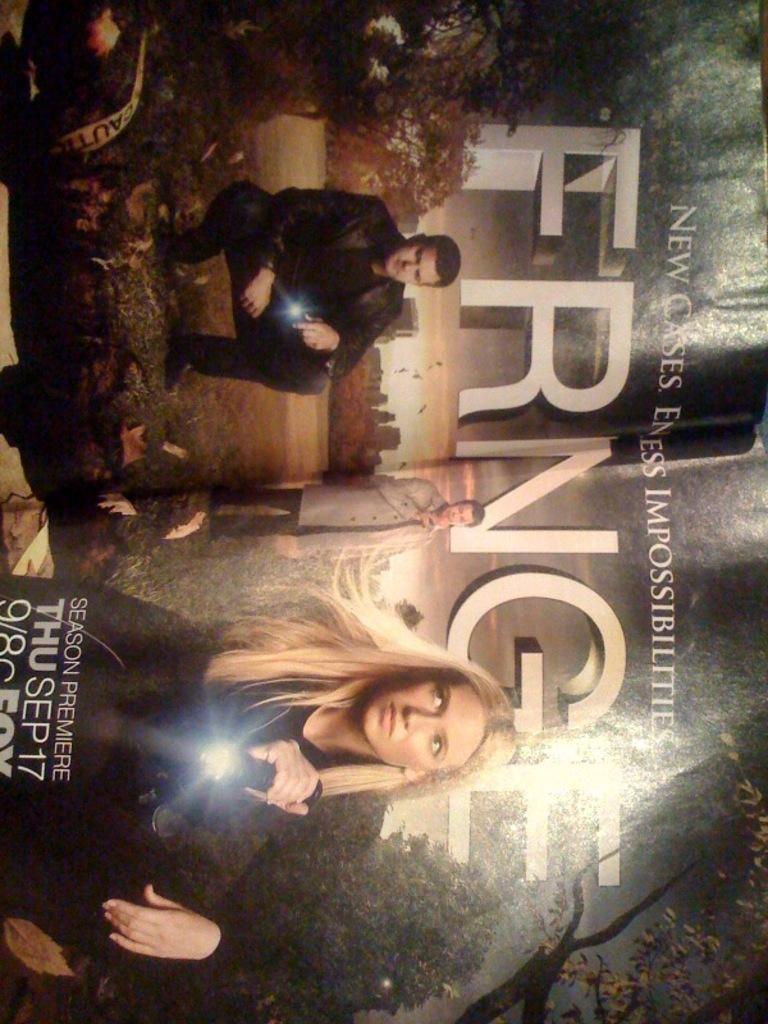What date is the season premiere?
Keep it short and to the point. Thu sep 17. What show is this advertising?
Keep it short and to the point. Fringe. 